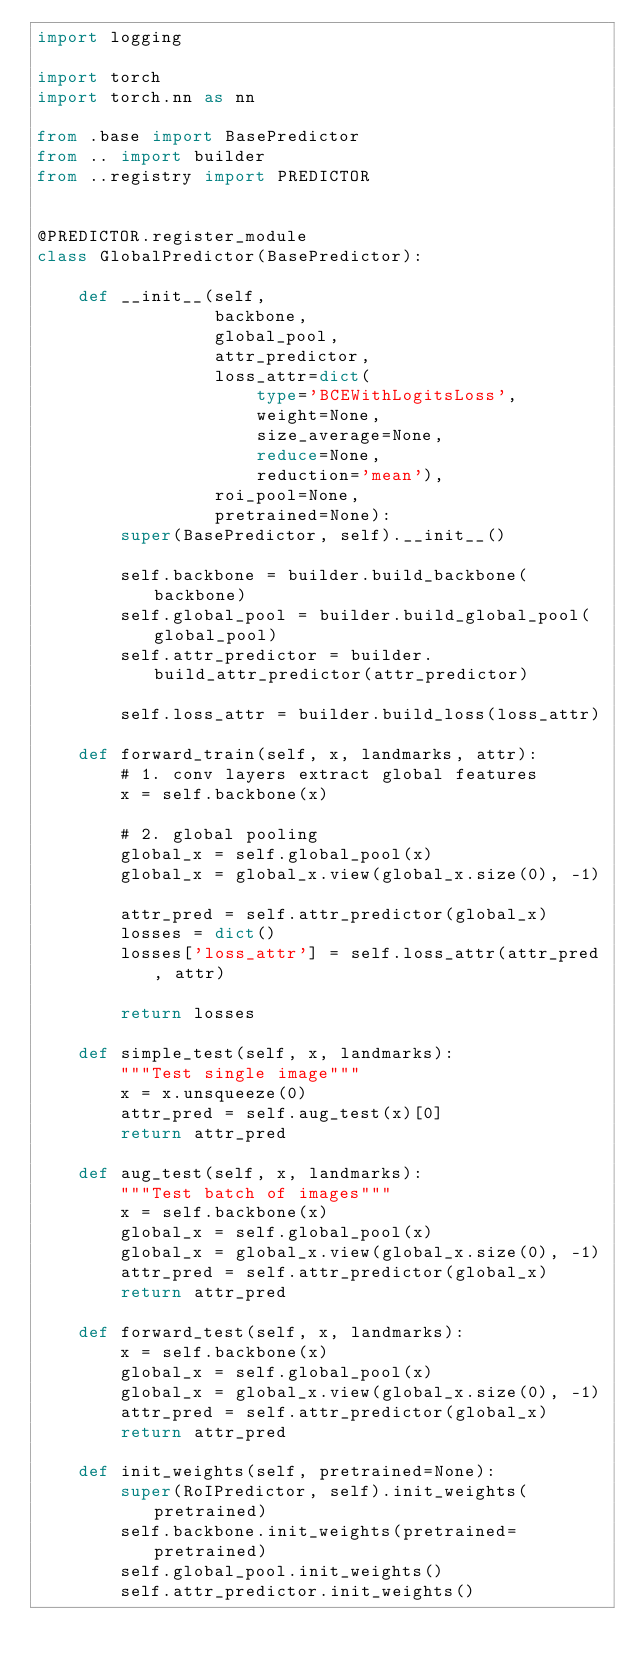<code> <loc_0><loc_0><loc_500><loc_500><_Python_>import logging

import torch
import torch.nn as nn

from .base import BasePredictor
from .. import builder
from ..registry import PREDICTOR


@PREDICTOR.register_module
class GlobalPredictor(BasePredictor):

    def __init__(self,
                 backbone,
                 global_pool,
                 attr_predictor,
                 loss_attr=dict(
                     type='BCEWithLogitsLoss',
                     weight=None,
                     size_average=None,
                     reduce=None,
                     reduction='mean'),
                 roi_pool=None,
                 pretrained=None):
        super(BasePredictor, self).__init__()

        self.backbone = builder.build_backbone(backbone)
        self.global_pool = builder.build_global_pool(global_pool)
        self.attr_predictor = builder.build_attr_predictor(attr_predictor)

        self.loss_attr = builder.build_loss(loss_attr)

    def forward_train(self, x, landmarks, attr):
        # 1. conv layers extract global features
        x = self.backbone(x)

        # 2. global pooling
        global_x = self.global_pool(x)
        global_x = global_x.view(global_x.size(0), -1)

        attr_pred = self.attr_predictor(global_x)
        losses = dict()
        losses['loss_attr'] = self.loss_attr(attr_pred, attr)

        return losses

    def simple_test(self, x, landmarks):
        """Test single image"""
        x = x.unsqueeze(0)
        attr_pred = self.aug_test(x)[0]
        return attr_pred

    def aug_test(self, x, landmarks):
        """Test batch of images"""
        x = self.backbone(x)
        global_x = self.global_pool(x)
        global_x = global_x.view(global_x.size(0), -1)
        attr_pred = self.attr_predictor(global_x)
        return attr_pred

    def forward_test(self, x, landmarks):
        x = self.backbone(x)
        global_x = self.global_pool(x)
        global_x = global_x.view(global_x.size(0), -1)
        attr_pred = self.attr_predictor(global_x)
        return attr_pred

    def init_weights(self, pretrained=None):
        super(RoIPredictor, self).init_weights(pretrained)
        self.backbone.init_weights(pretrained=pretrained)
        self.global_pool.init_weights()
        self.attr_predictor.init_weights()
</code> 